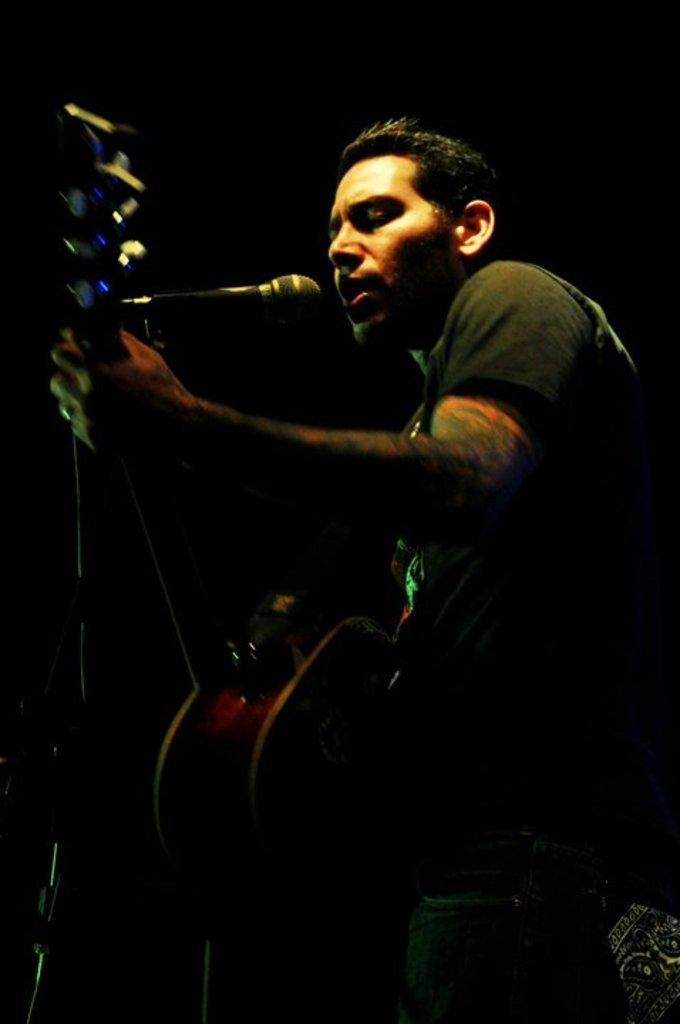Who is the main subject in the image? There is a man in the image. What is the man wearing? The man is wearing a black t-shirt. What is the man holding in the image? The man is holding a guitar. What is the man doing with the guitar? The man is playing the guitar. What is the man doing while playing the guitar? The man is singing on a microphone. Where are the ants located in the image? There are no ants present in the image. What type of secretary is assisting the man in the image? There is no secretary present in the image. 